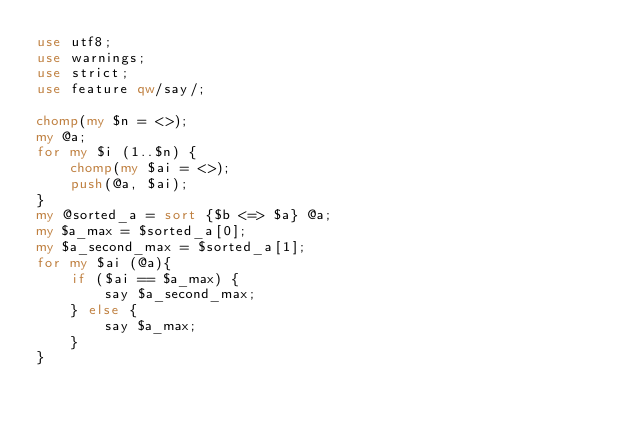Convert code to text. <code><loc_0><loc_0><loc_500><loc_500><_Perl_>use utf8;
use warnings;
use strict;
use feature qw/say/;

chomp(my $n = <>);
my @a;
for my $i (1..$n) {
    chomp(my $ai = <>);
    push(@a, $ai);
}
my @sorted_a = sort {$b <=> $a} @a;
my $a_max = $sorted_a[0];
my $a_second_max = $sorted_a[1];
for my $ai (@a){
    if ($ai == $a_max) {
        say $a_second_max;
    } else {
        say $a_max;
    }
}</code> 